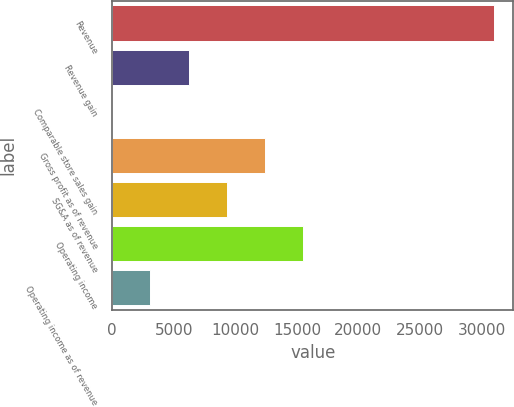Convert chart. <chart><loc_0><loc_0><loc_500><loc_500><bar_chart><fcel>Revenue<fcel>Revenue gain<fcel>Comparable store sales gain<fcel>Gross profit as of revenue<fcel>SG&A as of revenue<fcel>Operating income<fcel>Operating income as of revenue<nl><fcel>31031<fcel>6209.48<fcel>4.1<fcel>12414.9<fcel>9312.17<fcel>15517.5<fcel>3106.79<nl></chart> 